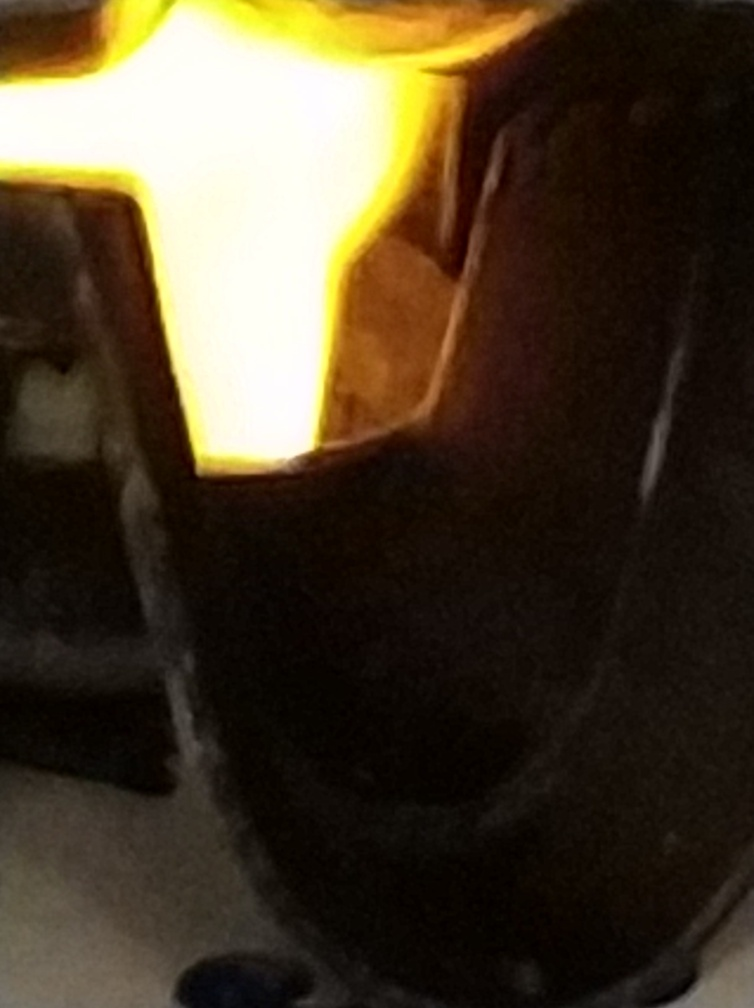Are the lighting and colors good? The image provided is quite blurred with an excessive exposure to light in the center, likely from an artificial light source, which hinders a proper assessment of color balance and results in an overexposed photograph. The lighting condition is suboptimal for evaluating the colors accurately, as the picture lacks clarity and sharpness. In a more general aesthetic sense, the quality of lighting and color is not up to standard due to these technical issues. 